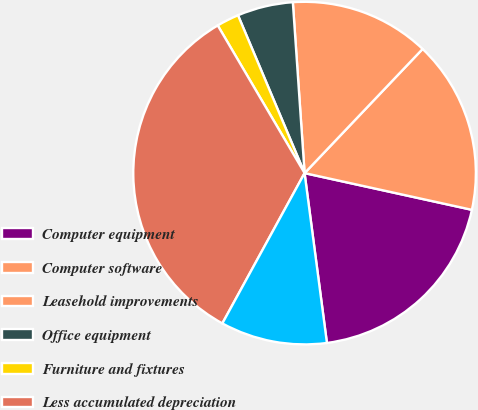Convert chart. <chart><loc_0><loc_0><loc_500><loc_500><pie_chart><fcel>Computer equipment<fcel>Computer software<fcel>Leasehold improvements<fcel>Office equipment<fcel>Furniture and fixtures<fcel>Less accumulated depreciation<fcel>Fixed assets net<nl><fcel>19.48%<fcel>16.34%<fcel>13.19%<fcel>5.26%<fcel>2.11%<fcel>33.57%<fcel>10.05%<nl></chart> 